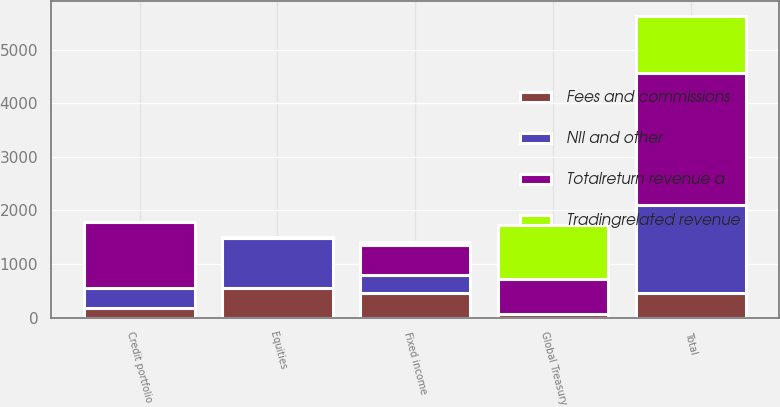Convert chart. <chart><loc_0><loc_0><loc_500><loc_500><stacked_bar_chart><ecel><fcel>Fixed income<fcel>Global Treasury<fcel>Credit portfolio<fcel>Equities<fcel>Total<nl><fcel>Fees and commissions<fcel>458<fcel>64<fcel>185<fcel>548<fcel>458<nl><fcel>NII and other<fcel>342<fcel>1<fcel>368<fcel>935<fcel>1646<nl><fcel>Tradingrelated revenue<fcel>56<fcel>1002<fcel>1<fcel>6<fcel>1065<nl><fcel>Totalreturn revenue a<fcel>550<fcel>659<fcel>1237<fcel>10<fcel>2456<nl></chart> 